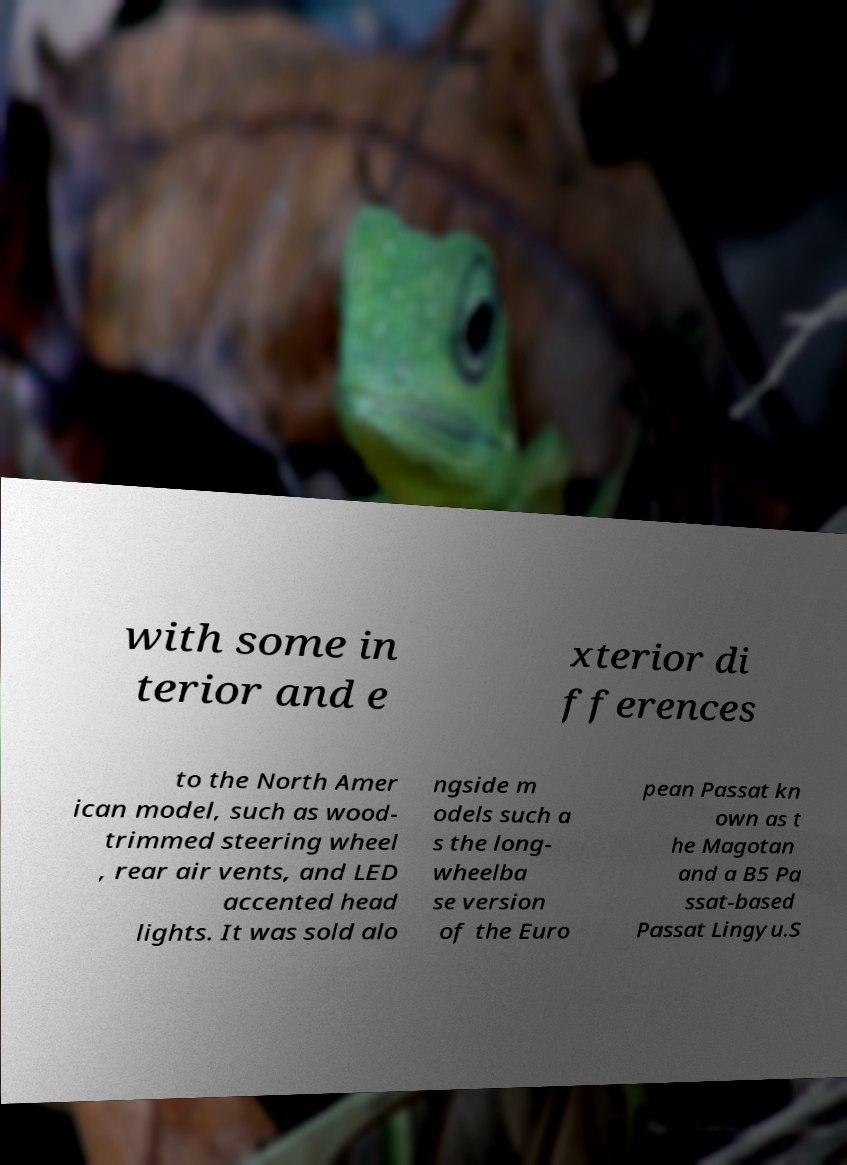Can you accurately transcribe the text from the provided image for me? with some in terior and e xterior di fferences to the North Amer ican model, such as wood- trimmed steering wheel , rear air vents, and LED accented head lights. It was sold alo ngside m odels such a s the long- wheelba se version of the Euro pean Passat kn own as t he Magotan and a B5 Pa ssat-based Passat Lingyu.S 